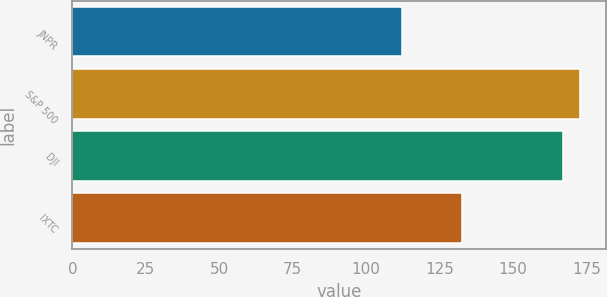<chart> <loc_0><loc_0><loc_500><loc_500><bar_chart><fcel>JNPR<fcel>S&P 500<fcel>DJI<fcel>IXTC<nl><fcel>112.34<fcel>172.87<fcel>166.87<fcel>132.54<nl></chart> 